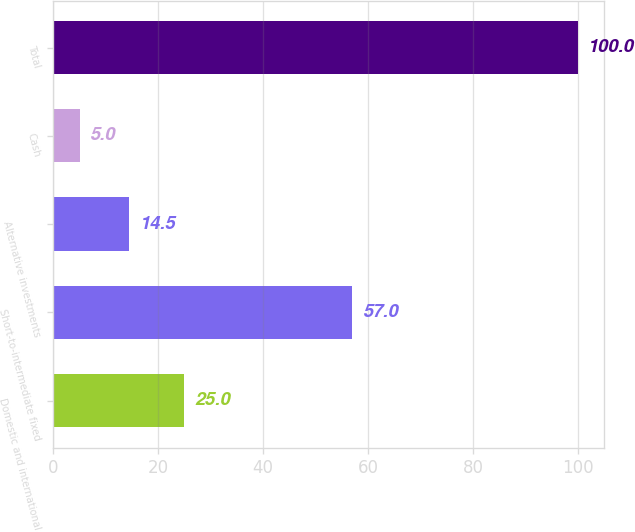Convert chart. <chart><loc_0><loc_0><loc_500><loc_500><bar_chart><fcel>Domestic and international<fcel>Short-to-intermediate fixed<fcel>Alternative investments<fcel>Cash<fcel>Total<nl><fcel>25<fcel>57<fcel>14.5<fcel>5<fcel>100<nl></chart> 